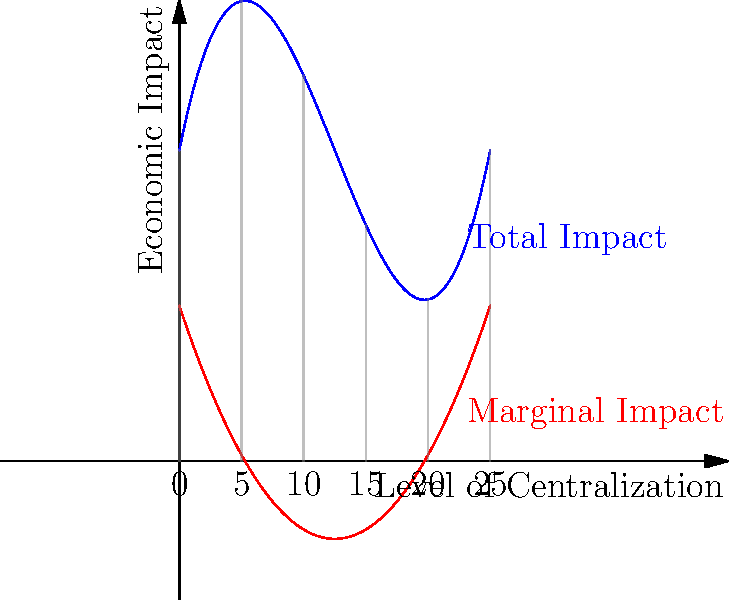The graph shows the total economic impact (blue curve) and marginal economic impact (red curve) of centralized regulations on local economies. If the total impact function is given by $f(x) = 0.1x^3 - 1.5x^2 + 5x + 10$, where $x$ represents the level of centralization:

a) At what level of centralization is the marginal impact maximized?
b) What is the economic interpretation of this point for a state representative advocating for centralized decision-making? To solve this problem, we need to follow these steps:

1) The marginal impact is represented by the derivative of the total impact function. So, we first need to find $f'(x)$:

   $f'(x) = 0.3x^2 - 3x + 5$

2) To find the maximum of the marginal impact, we need to find where its derivative equals zero:

   $f''(x) = 0.6x - 3$

   Set this equal to zero:
   $0.6x - 3 = 0$
   $0.6x = 3$
   $x = 5$

3) To confirm this is a maximum, we can check the second derivative:
   $f'''(x) = 0.6$, which is positive, confirming a minimum.

4) Therefore, the marginal impact is maximized when $x = 5$, which corresponds to a centralization level of 25 on the graph's scale.

5) Economic interpretation: At this point, the rate of change of the economic impact is at its highest. This means that for a small increase in centralization around this point, we get the largest possible increase in economic impact. For a state representative advocating for centralized decision-making, this represents the "sweet spot" where additional centralization yields the highest marginal benefit to the economy.

6) However, it's crucial to note that this is not where the total impact is maximized. The total impact continues to increase beyond this point, albeit at a decreasing rate. The state representative should consider this trade-off between marginal benefits and overall impact when making policy decisions.
Answer: a) 25
b) Point of highest marginal economic benefit from increased centralization 